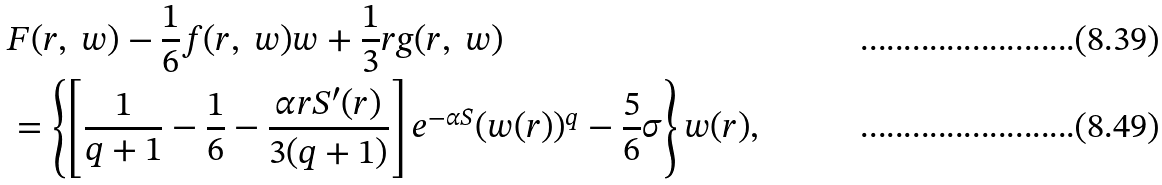<formula> <loc_0><loc_0><loc_500><loc_500>& F ( r , \ w ) - \frac { 1 } { 6 } f ( r , \ w ) w + \frac { 1 } { 3 } r g ( r , \ w ) \\ & = \left \{ \left [ \frac { 1 } { q + 1 } - \frac { 1 } { 6 } - \frac { \alpha r S ^ { \prime } ( r ) } { 3 ( q + 1 ) } \right ] e ^ { - \alpha S } ( w ( r ) ) ^ { q } - \frac { 5 } { 6 } \sigma \right \} w ( r ) ,</formula> 